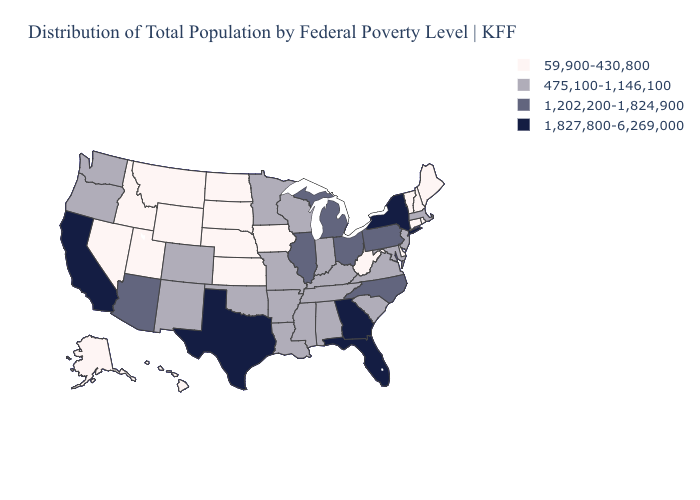Among the states that border Pennsylvania , does Maryland have the lowest value?
Answer briefly. No. What is the value of Arkansas?
Short answer required. 475,100-1,146,100. Among the states that border Arkansas , which have the highest value?
Quick response, please. Texas. What is the value of Virginia?
Keep it brief. 475,100-1,146,100. Does the map have missing data?
Quick response, please. No. Among the states that border South Carolina , which have the lowest value?
Give a very brief answer. North Carolina. Name the states that have a value in the range 1,827,800-6,269,000?
Keep it brief. California, Florida, Georgia, New York, Texas. Name the states that have a value in the range 59,900-430,800?
Answer briefly. Alaska, Connecticut, Delaware, Hawaii, Idaho, Iowa, Kansas, Maine, Montana, Nebraska, Nevada, New Hampshire, North Dakota, Rhode Island, South Dakota, Utah, Vermont, West Virginia, Wyoming. What is the value of New Mexico?
Quick response, please. 475,100-1,146,100. Does the map have missing data?
Short answer required. No. Name the states that have a value in the range 1,202,200-1,824,900?
Short answer required. Arizona, Illinois, Michigan, North Carolina, Ohio, Pennsylvania. What is the lowest value in the USA?
Write a very short answer. 59,900-430,800. Among the states that border Ohio , which have the highest value?
Write a very short answer. Michigan, Pennsylvania. Name the states that have a value in the range 59,900-430,800?
Concise answer only. Alaska, Connecticut, Delaware, Hawaii, Idaho, Iowa, Kansas, Maine, Montana, Nebraska, Nevada, New Hampshire, North Dakota, Rhode Island, South Dakota, Utah, Vermont, West Virginia, Wyoming. Which states have the lowest value in the USA?
Keep it brief. Alaska, Connecticut, Delaware, Hawaii, Idaho, Iowa, Kansas, Maine, Montana, Nebraska, Nevada, New Hampshire, North Dakota, Rhode Island, South Dakota, Utah, Vermont, West Virginia, Wyoming. 